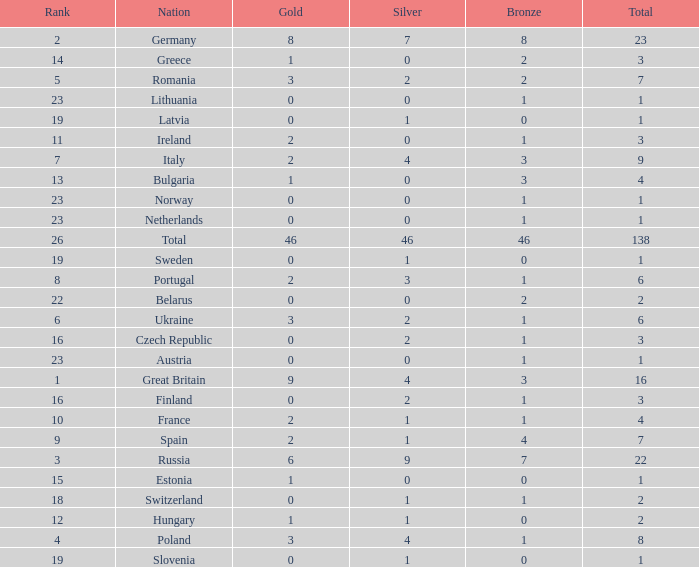When the total is larger than 1,and the bronze is less than 3, and silver larger than 2, and a gold larger than 2, what is the nation? Poland. Can you give me this table as a dict? {'header': ['Rank', 'Nation', 'Gold', 'Silver', 'Bronze', 'Total'], 'rows': [['2', 'Germany', '8', '7', '8', '23'], ['14', 'Greece', '1', '0', '2', '3'], ['5', 'Romania', '3', '2', '2', '7'], ['23', 'Lithuania', '0', '0', '1', '1'], ['19', 'Latvia', '0', '1', '0', '1'], ['11', 'Ireland', '2', '0', '1', '3'], ['7', 'Italy', '2', '4', '3', '9'], ['13', 'Bulgaria', '1', '0', '3', '4'], ['23', 'Norway', '0', '0', '1', '1'], ['23', 'Netherlands', '0', '0', '1', '1'], ['26', 'Total', '46', '46', '46', '138'], ['19', 'Sweden', '0', '1', '0', '1'], ['8', 'Portugal', '2', '3', '1', '6'], ['22', 'Belarus', '0', '0', '2', '2'], ['6', 'Ukraine', '3', '2', '1', '6'], ['16', 'Czech Republic', '0', '2', '1', '3'], ['23', 'Austria', '0', '0', '1', '1'], ['1', 'Great Britain', '9', '4', '3', '16'], ['16', 'Finland', '0', '2', '1', '3'], ['10', 'France', '2', '1', '1', '4'], ['9', 'Spain', '2', '1', '4', '7'], ['3', 'Russia', '6', '9', '7', '22'], ['15', 'Estonia', '1', '0', '0', '1'], ['18', 'Switzerland', '0', '1', '1', '2'], ['12', 'Hungary', '1', '1', '0', '2'], ['4', 'Poland', '3', '4', '1', '8'], ['19', 'Slovenia', '0', '1', '0', '1']]} 